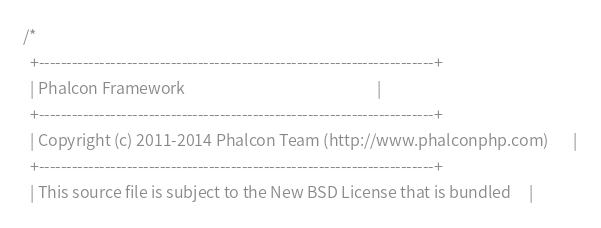Convert code to text. <code><loc_0><loc_0><loc_500><loc_500><_C_>
/*
  +------------------------------------------------------------------------+
  | Phalcon Framework                                                      |
  +------------------------------------------------------------------------+
  | Copyright (c) 2011-2014 Phalcon Team (http://www.phalconphp.com)       |
  +------------------------------------------------------------------------+
  | This source file is subject to the New BSD License that is bundled     |</code> 